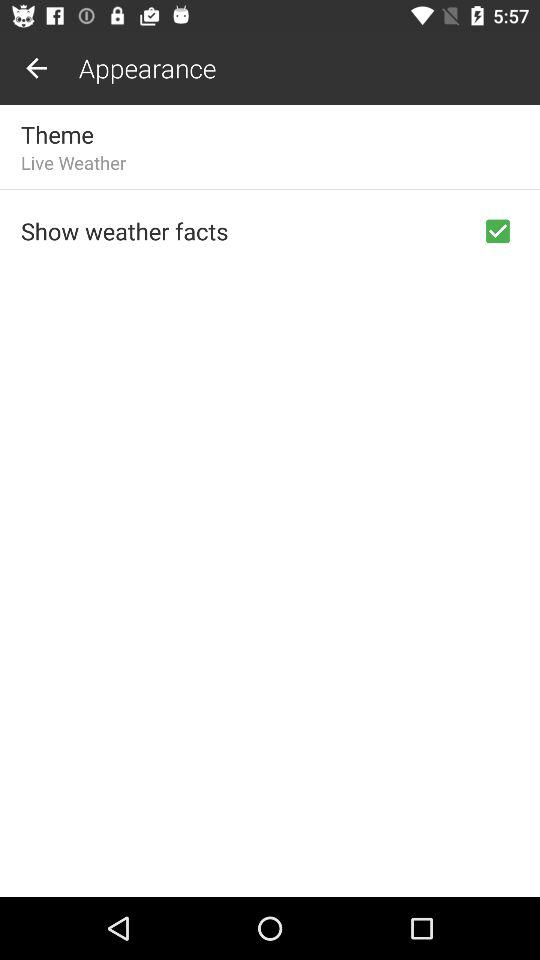What is the current weather?
When the provided information is insufficient, respond with <no answer>. <no answer> 